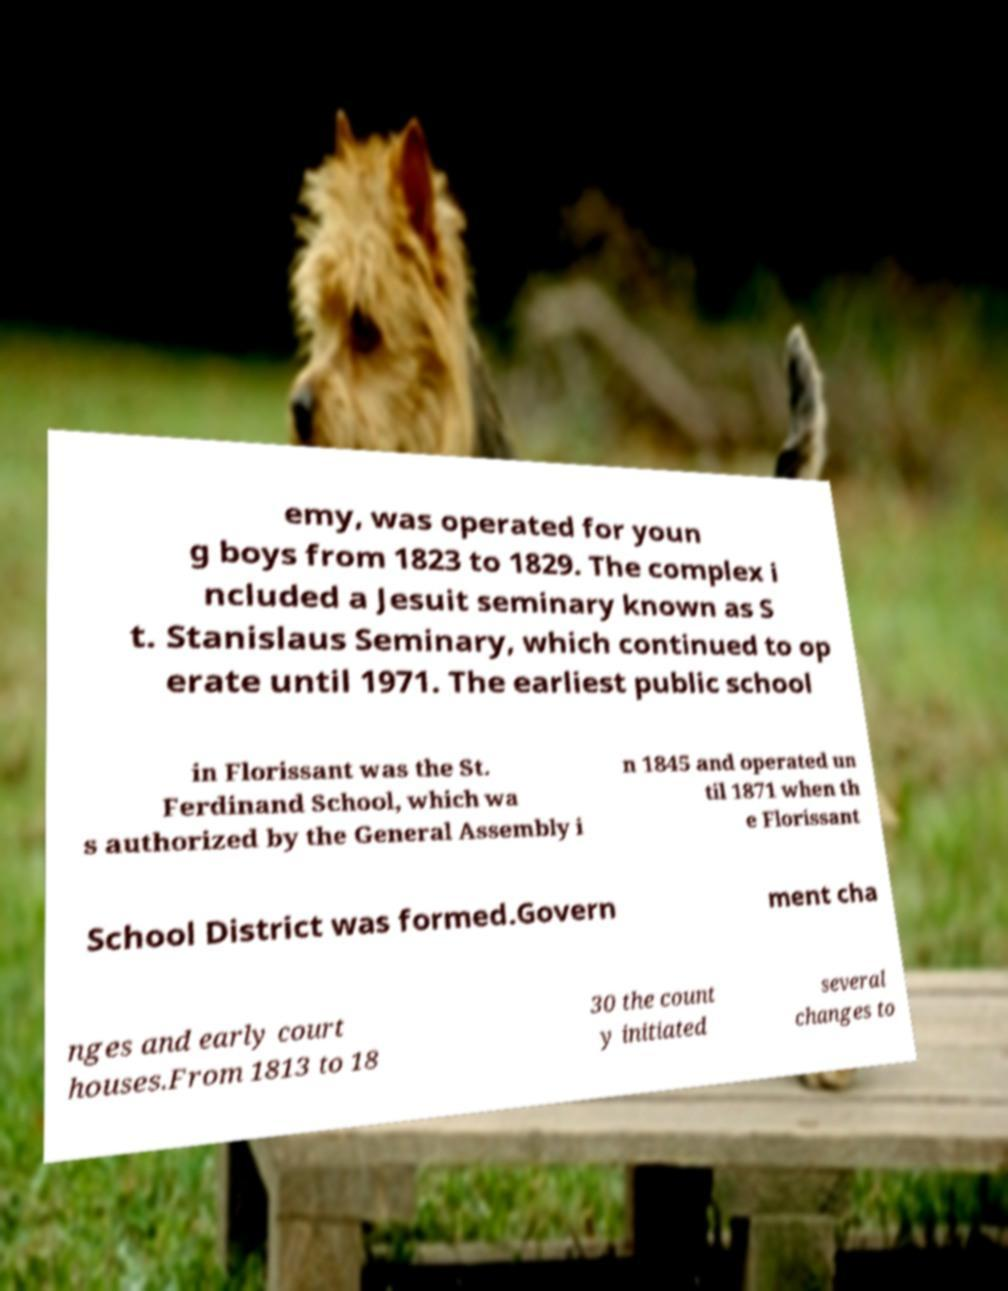Can you read and provide the text displayed in the image?This photo seems to have some interesting text. Can you extract and type it out for me? emy, was operated for youn g boys from 1823 to 1829. The complex i ncluded a Jesuit seminary known as S t. Stanislaus Seminary, which continued to op erate until 1971. The earliest public school in Florissant was the St. Ferdinand School, which wa s authorized by the General Assembly i n 1845 and operated un til 1871 when th e Florissant School District was formed.Govern ment cha nges and early court houses.From 1813 to 18 30 the count y initiated several changes to 